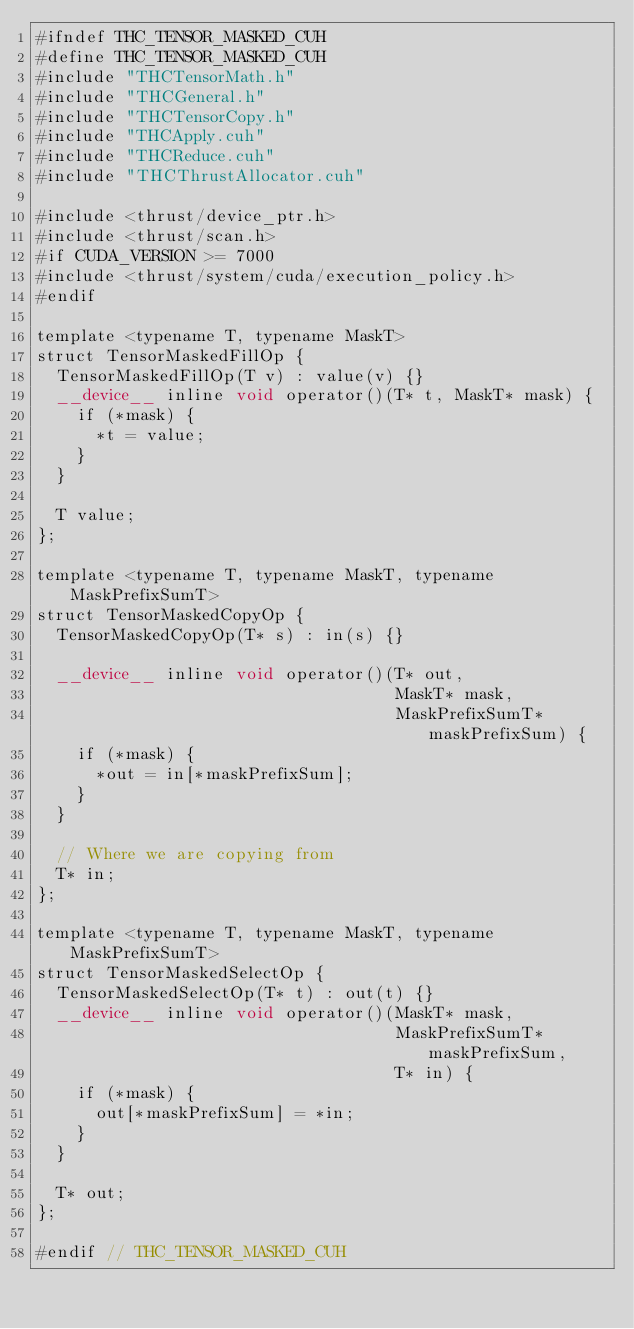<code> <loc_0><loc_0><loc_500><loc_500><_Cuda_>#ifndef THC_TENSOR_MASKED_CUH
#define THC_TENSOR_MASKED_CUH
#include "THCTensorMath.h"
#include "THCGeneral.h"
#include "THCTensorCopy.h"
#include "THCApply.cuh"
#include "THCReduce.cuh"
#include "THCThrustAllocator.cuh"

#include <thrust/device_ptr.h>
#include <thrust/scan.h>
#if CUDA_VERSION >= 7000
#include <thrust/system/cuda/execution_policy.h>
#endif

template <typename T, typename MaskT>
struct TensorMaskedFillOp {
  TensorMaskedFillOp(T v) : value(v) {}
  __device__ inline void operator()(T* t, MaskT* mask) {
    if (*mask) {
      *t = value;
    }
  }

  T value;
};

template <typename T, typename MaskT, typename MaskPrefixSumT>
struct TensorMaskedCopyOp {
  TensorMaskedCopyOp(T* s) : in(s) {}

  __device__ inline void operator()(T* out,
                                    MaskT* mask,
                                    MaskPrefixSumT* maskPrefixSum) {
    if (*mask) {
      *out = in[*maskPrefixSum];
    }
  }

  // Where we are copying from
  T* in;
};

template <typename T, typename MaskT, typename MaskPrefixSumT>
struct TensorMaskedSelectOp {
  TensorMaskedSelectOp(T* t) : out(t) {}
  __device__ inline void operator()(MaskT* mask,
                                    MaskPrefixSumT* maskPrefixSum,
                                    T* in) {
    if (*mask) {
      out[*maskPrefixSum] = *in;
    }
  }

  T* out;
};

#endif // THC_TENSOR_MASKED_CUH
</code> 